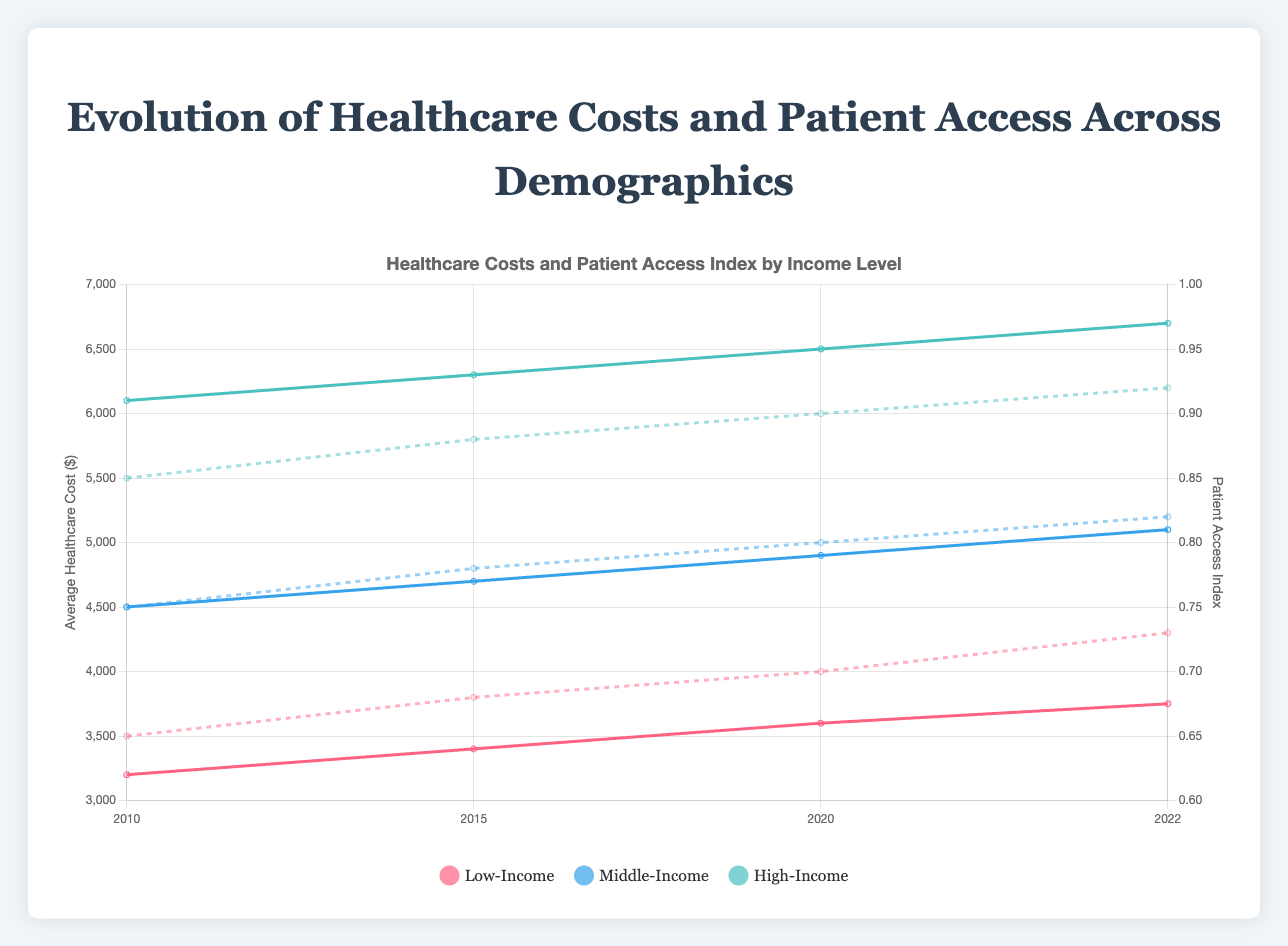What is the average healthcare cost for the Middle-Income demographic in 2022? To find the average healthcare cost for the Middle-Income demographic in 2022, look at the 'Middle-Income Cost' line on the chart for the year 2022 and read the value.
Answer: 5100.45 How did patient access for the Low-Income demographic change from 2010 to 2022? Locate the 'Low-Income Access' dashed line on the chart and compare the values for the years 2010 and 2022.
Answer: Increased from 0.65 to 0.73 Which demographic had the highest average healthcare cost in 2020? Compare the line heights for 'Low-Income', 'Middle-Income', and 'High-Income' costs for the year 2020. The highest line indicates the 'High-Income' demographic.
Answer: High-Income Between 2015 and 2020, which demographic saw the largest increase in patient access index? Check the dashed lines representing patient access for each demographic between 2015 and 2020 and calculate the increase for each. The Middle-Income demographic's index increased from 0.78 to 0.80 (0.02), which is the largest increment.
Answer: Middle-Income What is the difference between the average healthcare costs of Low-Income and High-Income demographics in 2022? Find the values for 'Low-Income Cost' and 'High-Income Cost' lines in 2022, and subtract the Low-Income value from the High-Income value (6700.80 - 3750.60).
Answer: 2950.20 Which demographic shows the most consistent increase in both healthcare costs and patient access index from 2010 to 2022? Evaluate the trends for each demographic in both solid and dashed lines over the years. 'High-Income' shows the most consistent increases in both healthcare costs and patient access index.
Answer: High-Income Compare the patient access index of Middle-Income demographic in 2010 and 2022. Did it increase or decrease, and by how much? Locate the 'Middle-Income Access' dashed line for 2010 and 2022. The value increases from 0.75 to 0.82, which is an increase of 0.07.
Answer: Increased by 0.07 How much did the average healthcare cost increase for Low-Income demographic from 2010 to 2022? Compare the values for 'Low-Income Cost' at 2010 and 2022, then subtract the 2010 value from the 2022 value (3750.60 - 3200.50).
Answer: 550.10 